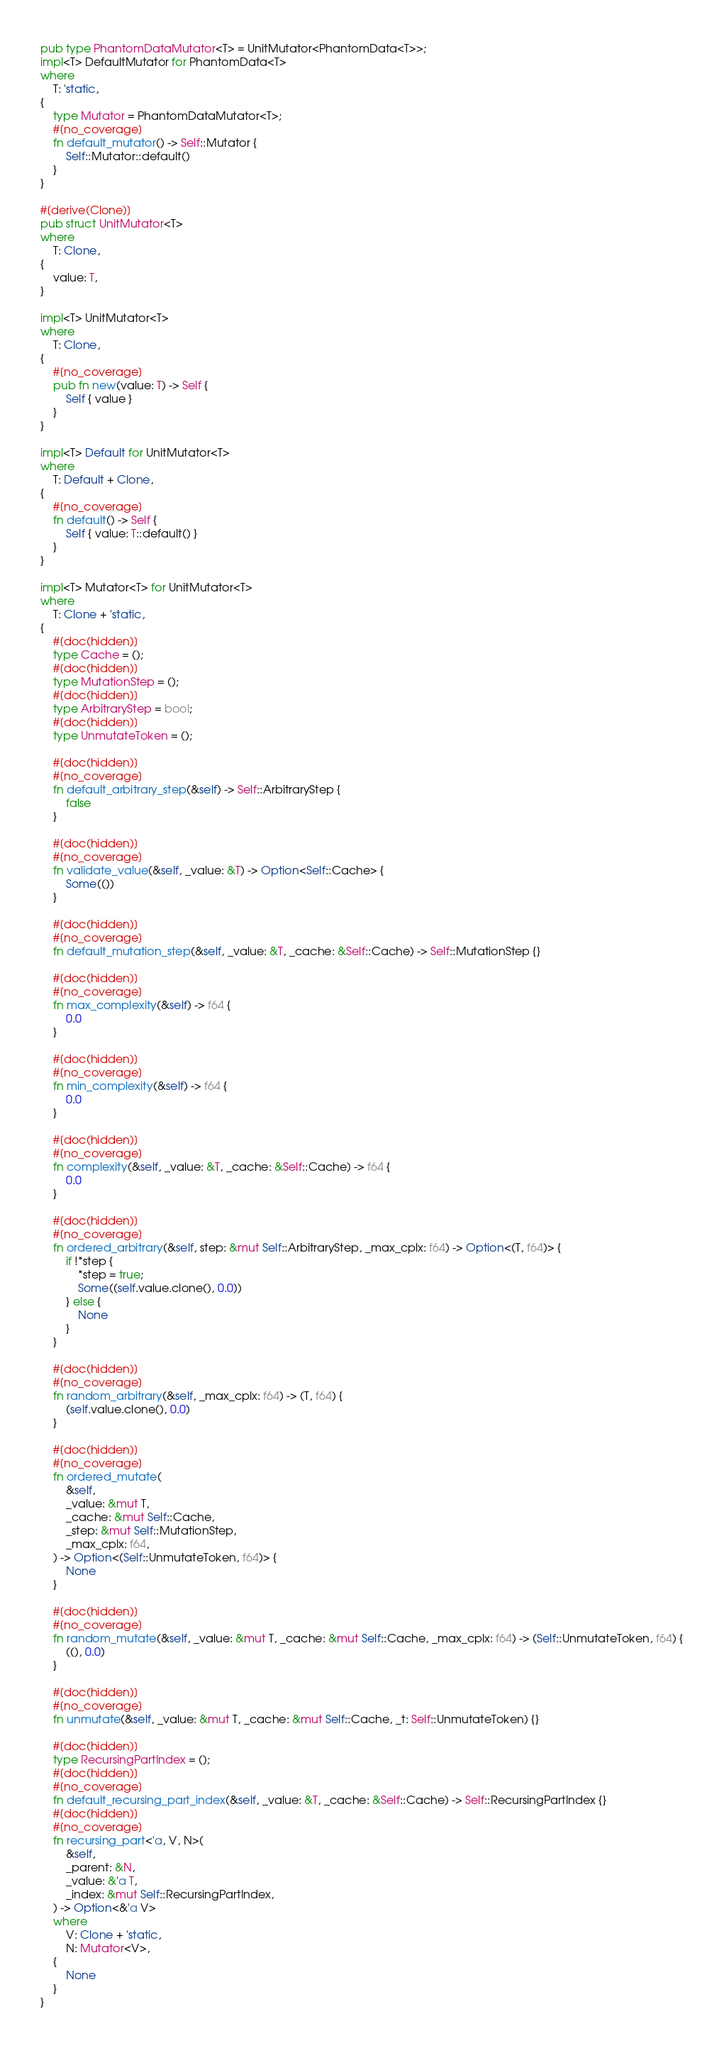Convert code to text. <code><loc_0><loc_0><loc_500><loc_500><_Rust_>pub type PhantomDataMutator<T> = UnitMutator<PhantomData<T>>;
impl<T> DefaultMutator for PhantomData<T>
where
    T: 'static,
{
    type Mutator = PhantomDataMutator<T>;
    #[no_coverage]
    fn default_mutator() -> Self::Mutator {
        Self::Mutator::default()
    }
}

#[derive(Clone)]
pub struct UnitMutator<T>
where
    T: Clone,
{
    value: T,
}

impl<T> UnitMutator<T>
where
    T: Clone,
{
    #[no_coverage]
    pub fn new(value: T) -> Self {
        Self { value }
    }
}

impl<T> Default for UnitMutator<T>
where
    T: Default + Clone,
{
    #[no_coverage]
    fn default() -> Self {
        Self { value: T::default() }
    }
}

impl<T> Mutator<T> for UnitMutator<T>
where
    T: Clone + 'static,
{
    #[doc(hidden)]
    type Cache = ();
    #[doc(hidden)]
    type MutationStep = ();
    #[doc(hidden)]
    type ArbitraryStep = bool;
    #[doc(hidden)]
    type UnmutateToken = ();

    #[doc(hidden)]
    #[no_coverage]
    fn default_arbitrary_step(&self) -> Self::ArbitraryStep {
        false
    }

    #[doc(hidden)]
    #[no_coverage]
    fn validate_value(&self, _value: &T) -> Option<Self::Cache> {
        Some(())
    }

    #[doc(hidden)]
    #[no_coverage]
    fn default_mutation_step(&self, _value: &T, _cache: &Self::Cache) -> Self::MutationStep {}

    #[doc(hidden)]
    #[no_coverage]
    fn max_complexity(&self) -> f64 {
        0.0
    }

    #[doc(hidden)]
    #[no_coverage]
    fn min_complexity(&self) -> f64 {
        0.0
    }

    #[doc(hidden)]
    #[no_coverage]
    fn complexity(&self, _value: &T, _cache: &Self::Cache) -> f64 {
        0.0
    }

    #[doc(hidden)]
    #[no_coverage]
    fn ordered_arbitrary(&self, step: &mut Self::ArbitraryStep, _max_cplx: f64) -> Option<(T, f64)> {
        if !*step {
            *step = true;
            Some((self.value.clone(), 0.0))
        } else {
            None
        }
    }

    #[doc(hidden)]
    #[no_coverage]
    fn random_arbitrary(&self, _max_cplx: f64) -> (T, f64) {
        (self.value.clone(), 0.0)
    }

    #[doc(hidden)]
    #[no_coverage]
    fn ordered_mutate(
        &self,
        _value: &mut T,
        _cache: &mut Self::Cache,
        _step: &mut Self::MutationStep,
        _max_cplx: f64,
    ) -> Option<(Self::UnmutateToken, f64)> {
        None
    }

    #[doc(hidden)]
    #[no_coverage]
    fn random_mutate(&self, _value: &mut T, _cache: &mut Self::Cache, _max_cplx: f64) -> (Self::UnmutateToken, f64) {
        ((), 0.0)
    }

    #[doc(hidden)]
    #[no_coverage]
    fn unmutate(&self, _value: &mut T, _cache: &mut Self::Cache, _t: Self::UnmutateToken) {}

    #[doc(hidden)]
    type RecursingPartIndex = ();
    #[doc(hidden)]
    #[no_coverage]
    fn default_recursing_part_index(&self, _value: &T, _cache: &Self::Cache) -> Self::RecursingPartIndex {}
    #[doc(hidden)]
    #[no_coverage]
    fn recursing_part<'a, V, N>(
        &self,
        _parent: &N,
        _value: &'a T,
        _index: &mut Self::RecursingPartIndex,
    ) -> Option<&'a V>
    where
        V: Clone + 'static,
        N: Mutator<V>,
    {
        None
    }
}
</code> 